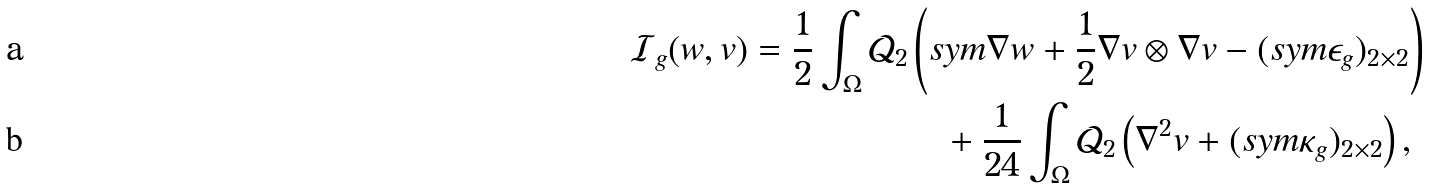Convert formula to latex. <formula><loc_0><loc_0><loc_500><loc_500>\mathcal { I } _ { g } ( w , v ) = \frac { 1 } { 2 } \int _ { \Omega } \mathcal { Q } _ { 2 } & \left ( s y m \nabla w + \frac { 1 } { 2 } \nabla v \otimes \nabla v - ( s y m \epsilon _ { g } ) _ { 2 \times 2 } \right ) \\ & \quad + \frac { 1 } { 2 4 } \int _ { \Omega } \mathcal { Q } _ { 2 } \left ( \nabla ^ { 2 } v + ( s y m \kappa _ { g } ) _ { 2 \times 2 } \right ) ,</formula> 